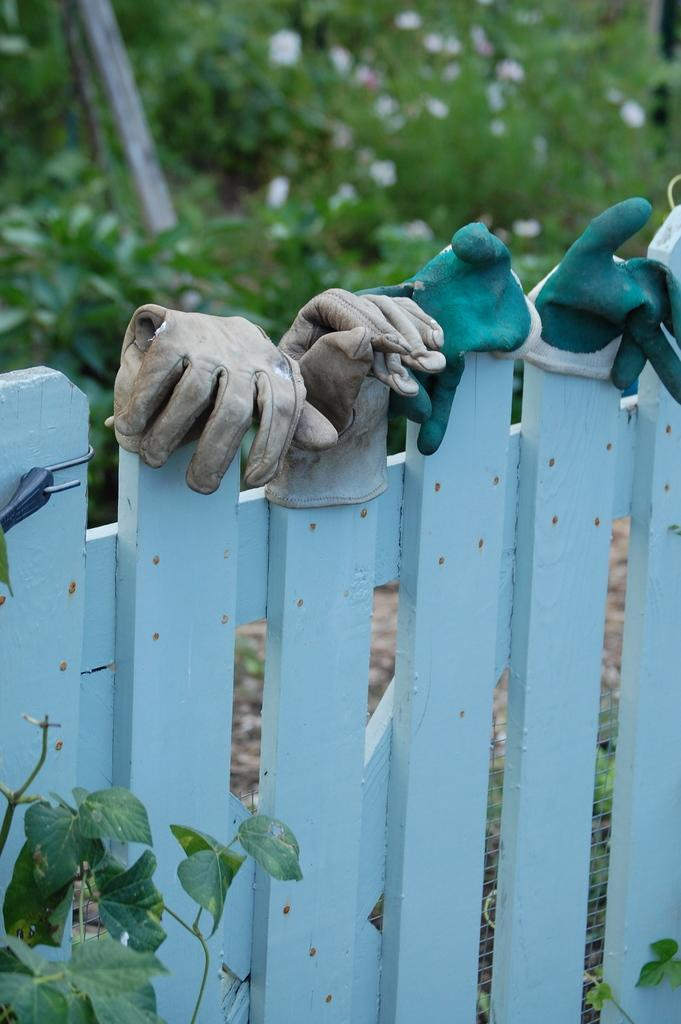What is the main object in the image? There is a fencing in the image. What is attached to the fencing? Gloves are hanging on the fencing. Can you describe any other objects in the image? There is a plant in the image. What can be seen in the background of the image? The background of the image is blurred and green. How many trucks are parked behind the plant in the image? There are no trucks present in the image; it only features a fencing, gloves, and a plant. Can you hear someone coughing in the image? The image is silent, and there is no indication of any sound, including coughing. 